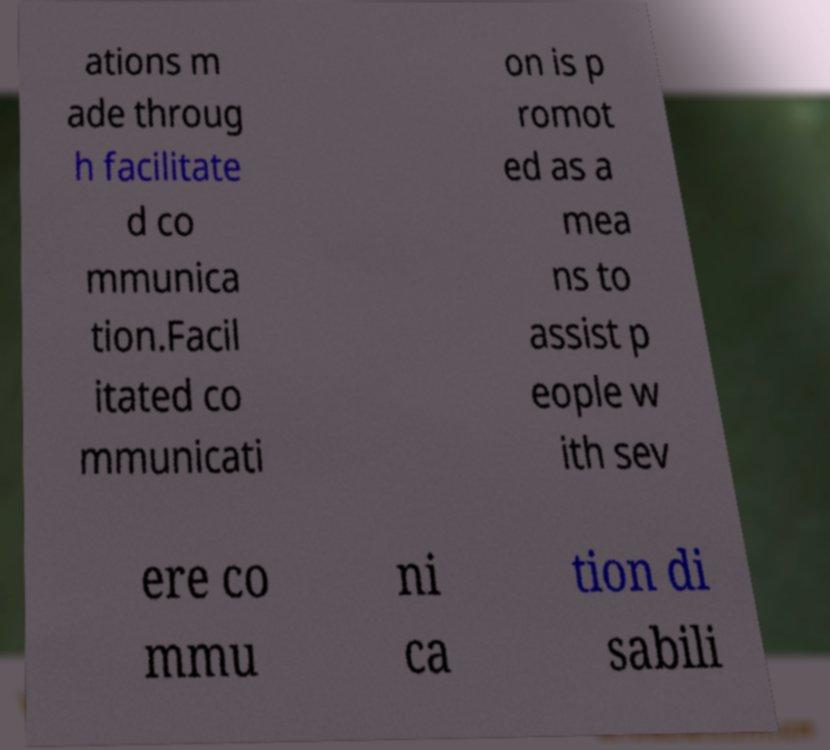Please identify and transcribe the text found in this image. ations m ade throug h facilitate d co mmunica tion.Facil itated co mmunicati on is p romot ed as a mea ns to assist p eople w ith sev ere co mmu ni ca tion di sabili 